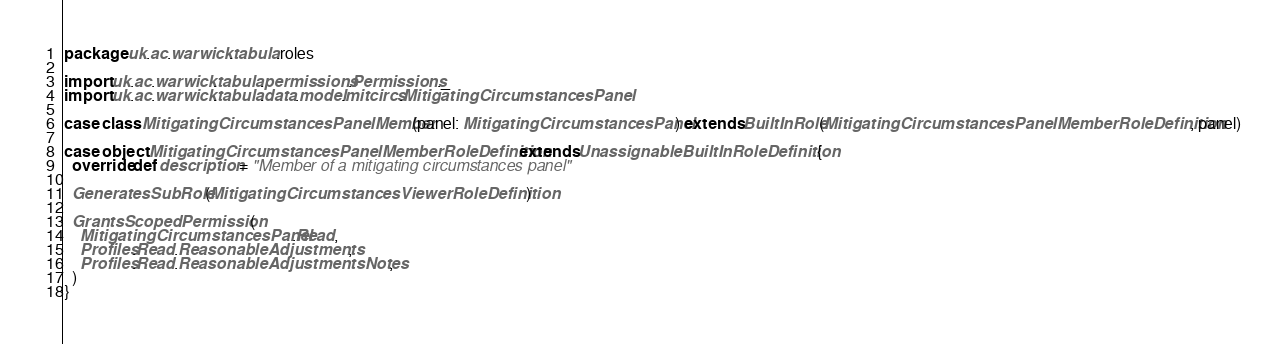Convert code to text. <code><loc_0><loc_0><loc_500><loc_500><_Scala_>package uk.ac.warwick.tabula.roles

import uk.ac.warwick.tabula.permissions.Permissions._
import uk.ac.warwick.tabula.data.model.mitcircs.MitigatingCircumstancesPanel

case class MitigatingCircumstancesPanelMember(panel: MitigatingCircumstancesPanel) extends BuiltInRole(MitigatingCircumstancesPanelMemberRoleDefinition, panel)

case object MitigatingCircumstancesPanelMemberRoleDefinition extends UnassignableBuiltInRoleDefinition {
  override def description = "Member of a mitigating circumstances panel"

  GeneratesSubRole(MitigatingCircumstancesViewerRoleDefinition)

  GrantsScopedPermission(
    MitigatingCircumstancesPanel.Read,
    Profiles.Read.ReasonableAdjustments,
    Profiles.Read.ReasonableAdjustmentsNotes,
  )
}
</code> 